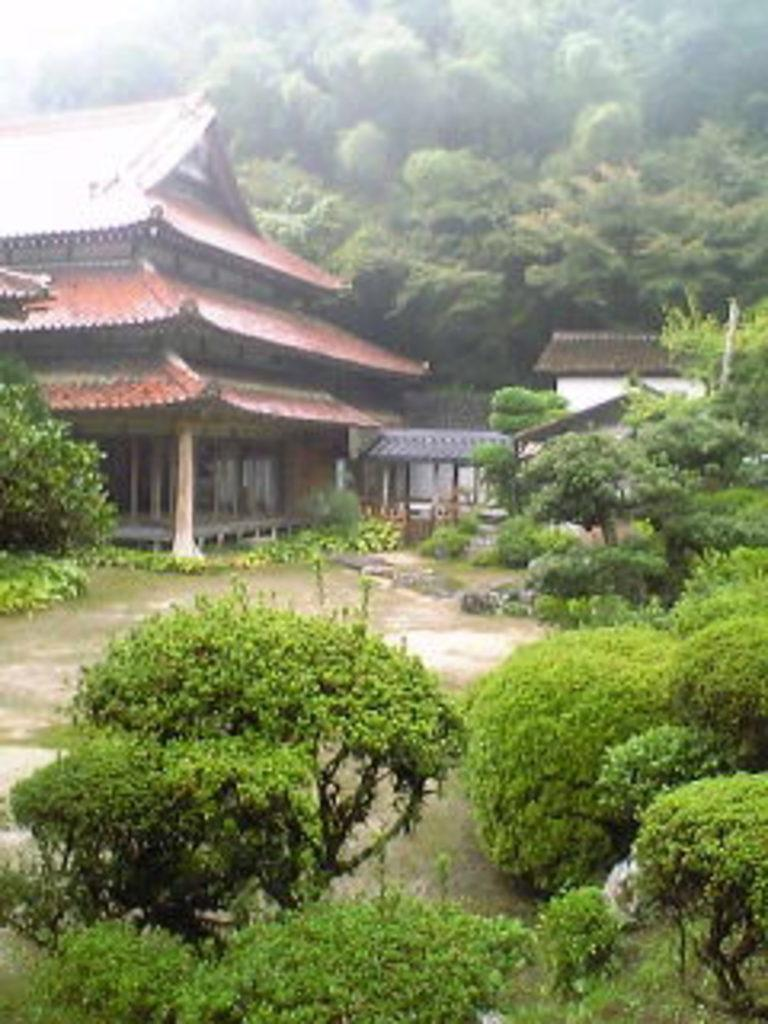What type of vegetation can be seen on the left side of the image? There are trees on the left side of the image. What type of vegetation can be seen on the right side of the image? There are trees on the right side of the image. What type of vegetation can be seen at the bottom of the image? There are trees at the bottom of the image. What type of vegetation can be seen in the background of the image? There are trees in the background of the image. What type of structure is in the foreground of the image? There is a house in the foreground of the image. What is a noticeable feature of the house? The house has red bricks on it. What type of bun is being used to hold the hour in the image? There is no bun or hour present in the image; it features trees and a house with red bricks. How many bushes are visible in the image? There are no bushes mentioned in the provided facts; only trees are mentioned. 